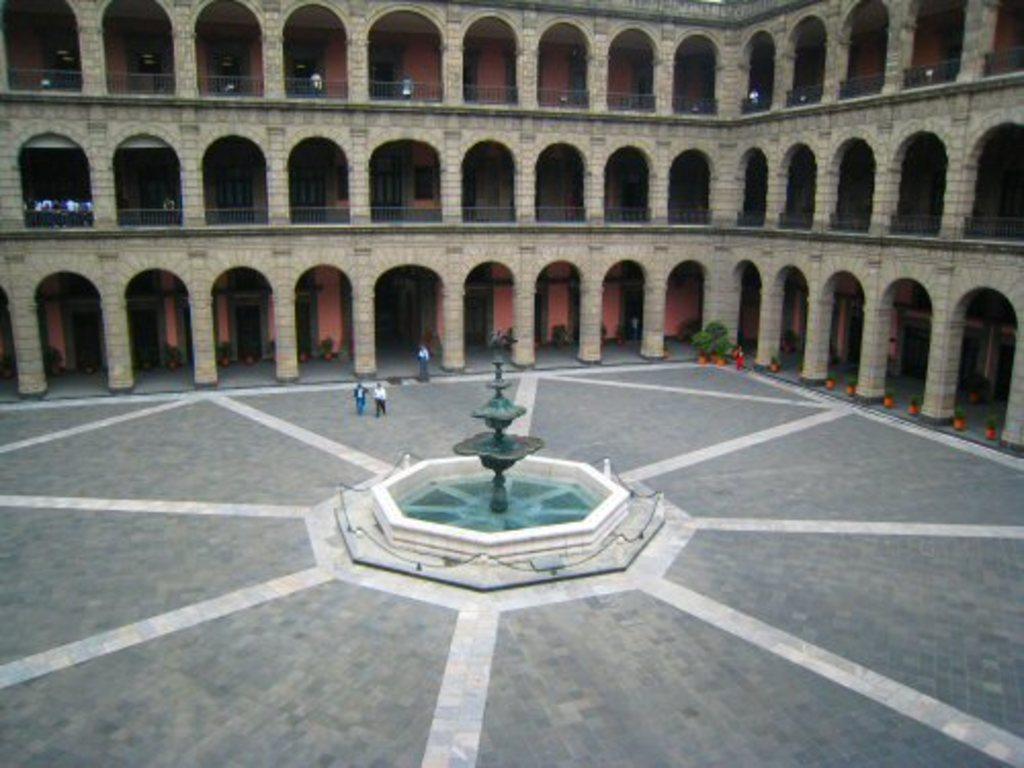How would you summarize this image in a sentence or two? In the center of the image there is a building and we can see people. At the bottom there is a fountain and we can see planets placed in the flower pots. 